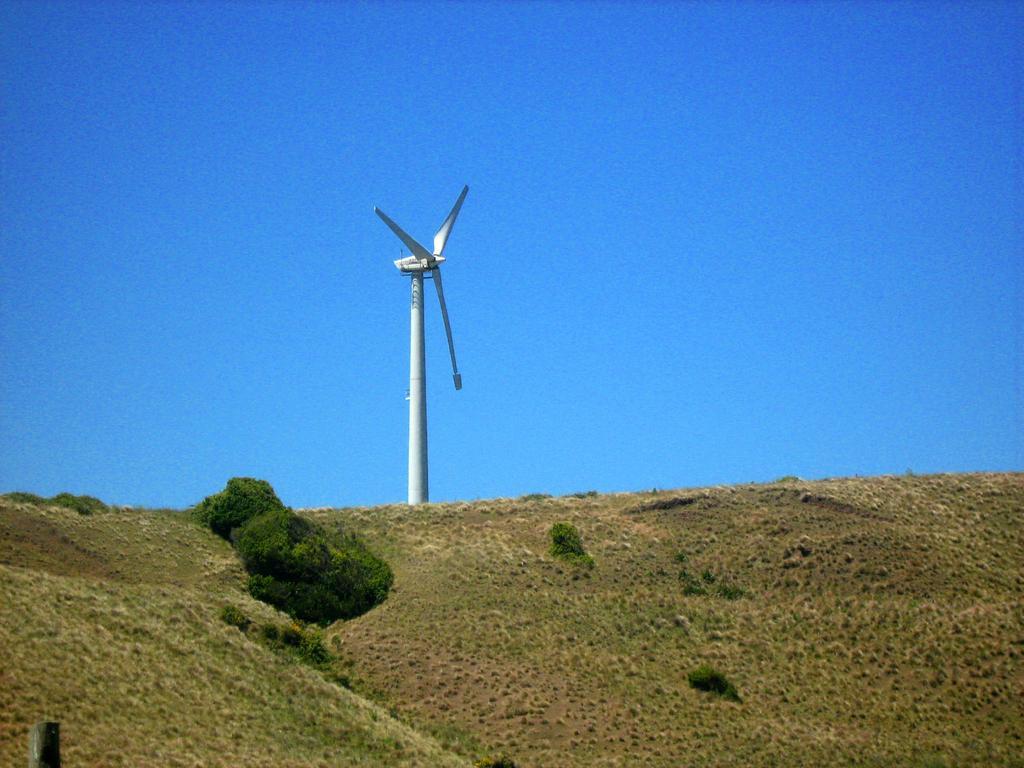How would you summarize this image in a sentence or two? In this image, we can see the windmill. At the bottom of the image, we can see plants and pole. In the background, there is the sky. 